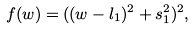<formula> <loc_0><loc_0><loc_500><loc_500>f ( w ) = ( ( w - l _ { 1 } ) ^ { 2 } + s _ { 1 } ^ { 2 } ) ^ { 2 } ,</formula> 